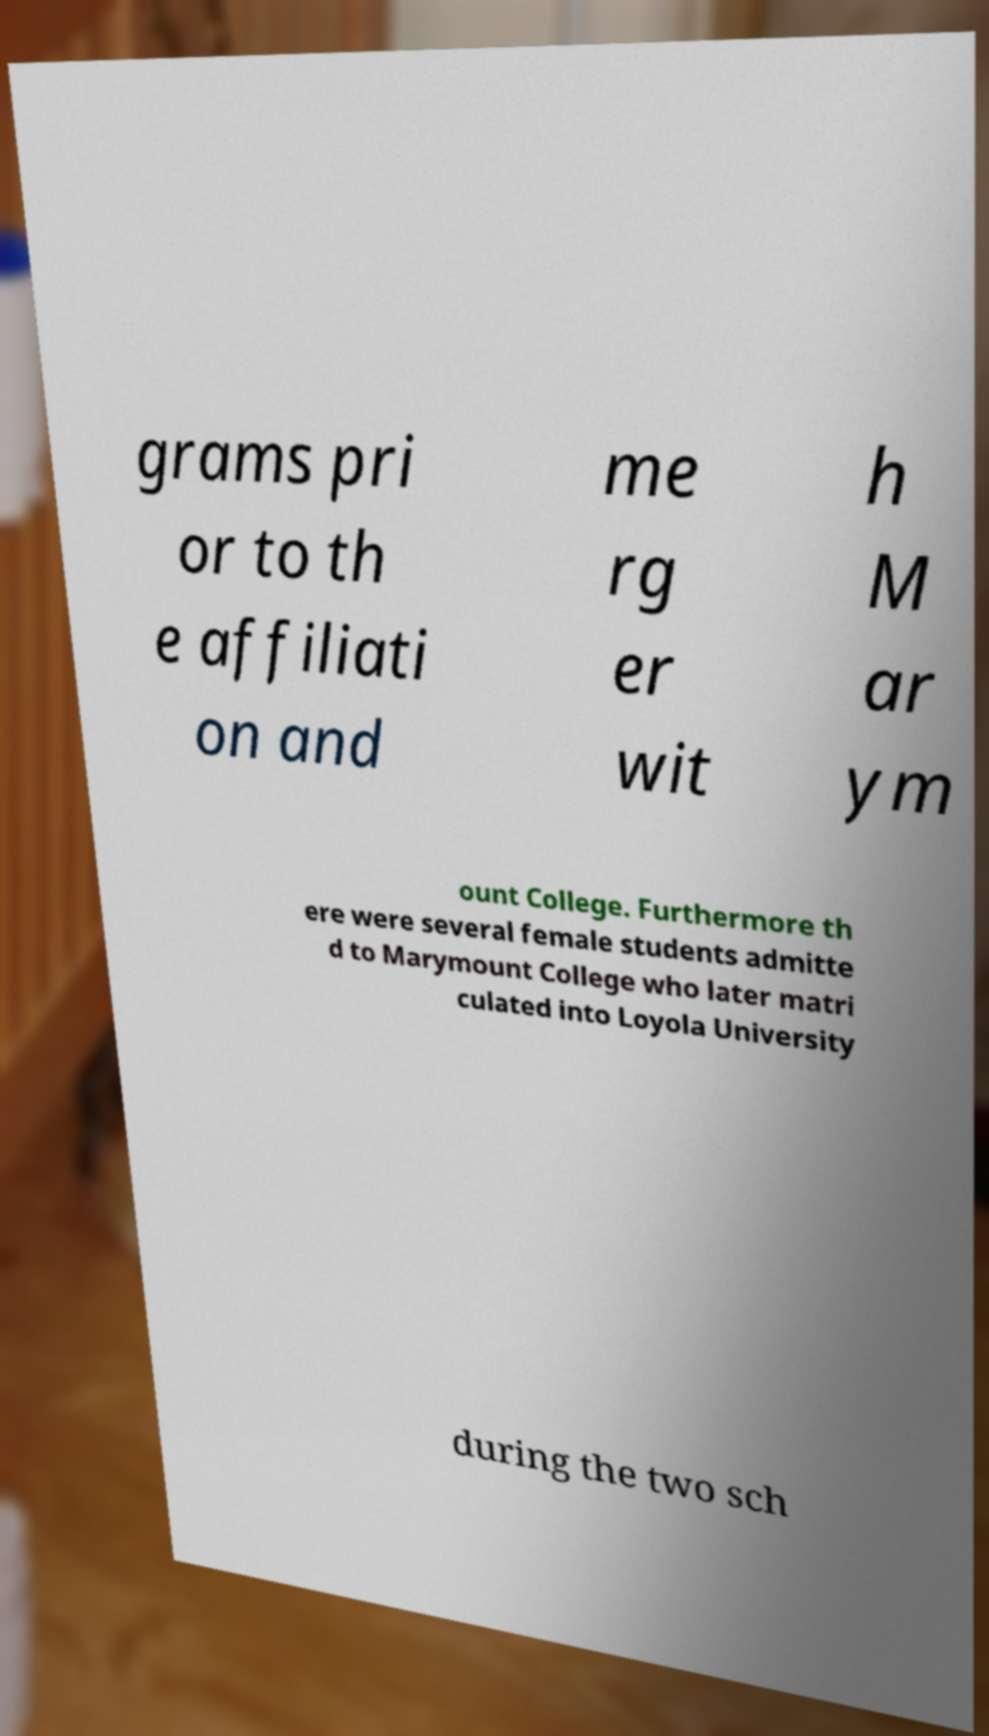There's text embedded in this image that I need extracted. Can you transcribe it verbatim? grams pri or to th e affiliati on and me rg er wit h M ar ym ount College. Furthermore th ere were several female students admitte d to Marymount College who later matri culated into Loyola University during the two sch 